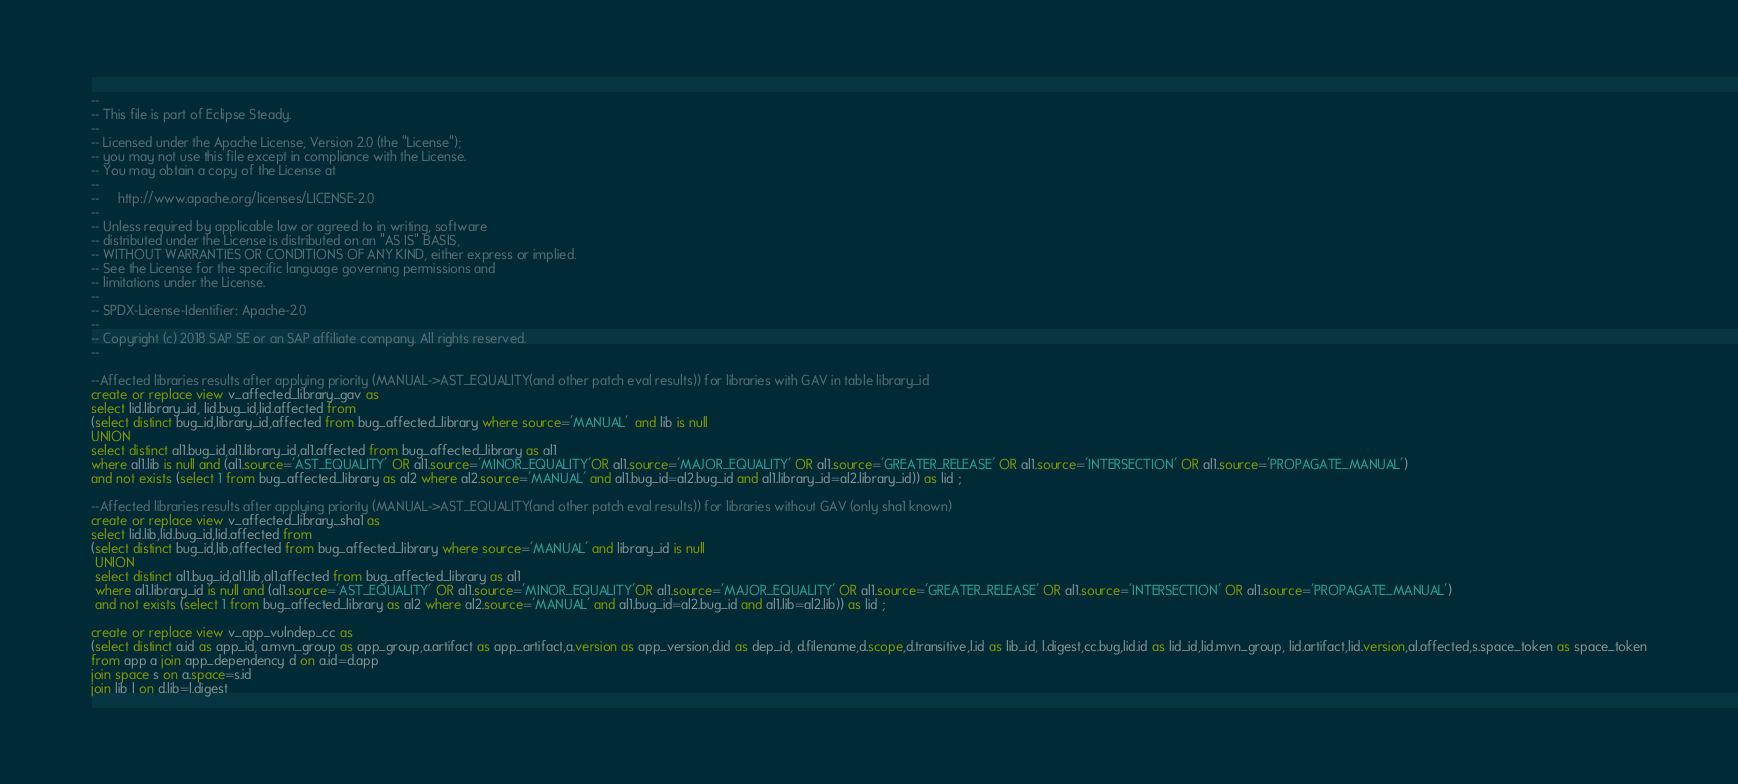<code> <loc_0><loc_0><loc_500><loc_500><_SQL_>--
-- This file is part of Eclipse Steady.
--
-- Licensed under the Apache License, Version 2.0 (the "License");
-- you may not use this file except in compliance with the License.
-- You may obtain a copy of the License at
--
--     http://www.apache.org/licenses/LICENSE-2.0
--
-- Unless required by applicable law or agreed to in writing, software
-- distributed under the License is distributed on an "AS IS" BASIS,
-- WITHOUT WARRANTIES OR CONDITIONS OF ANY KIND, either express or implied.
-- See the License for the specific language governing permissions and
-- limitations under the License.
--
-- SPDX-License-Identifier: Apache-2.0
--
-- Copyright (c) 2018 SAP SE or an SAP affiliate company. All rights reserved.
--

--Affected libraries results after applying priority (MANUAL->AST_EQUALITY(and other patch eval results)) for libraries with GAV in table library_id
create or replace view v_affected_library_gav as
select lid.library_id, lid.bug_id,lid.affected from 
(select distinct bug_id,library_id,affected from bug_affected_library where source='MANUAL'  and lib is null
UNION 
select distinct al1.bug_id,al1.library_id,al1.affected from bug_affected_library as al1
where al1.lib is null and (al1.source='AST_EQUALITY' OR al1.source='MINOR_EQUALITY'OR al1.source='MAJOR_EQUALITY' OR al1.source='GREATER_RELEASE' OR al1.source='INTERSECTION' OR al1.source='PROPAGATE_MANUAL')
and not exists (select 1 from bug_affected_library as al2 where al2.source='MANUAL' and al1.bug_id=al2.bug_id and al1.library_id=al2.library_id)) as lid ;

--Affected libraries results after applying priority (MANUAL->AST_EQUALITY(and other patch eval results)) for libraries without GAV (only sha1 known)
create or replace view v_affected_library_sha1 as
select lid.lib,lid.bug_id,lid.affected from 
(select distinct bug_id,lib,affected from bug_affected_library where source='MANUAL' and library_id is null 
 UNION 
 select distinct al1.bug_id,al1.lib,al1.affected from bug_affected_library as al1
 where al1.library_id is null and (al1.source='AST_EQUALITY' OR al1.source='MINOR_EQUALITY'OR al1.source='MAJOR_EQUALITY' OR al1.source='GREATER_RELEASE' OR al1.source='INTERSECTION' OR al1.source='PROPAGATE_MANUAL') 
 and not exists (select 1 from bug_affected_library as al2 where al2.source='MANUAL' and al1.bug_id=al2.bug_id and al1.lib=al2.lib)) as lid ;

create or replace view v_app_vulndep_cc as 
(select distinct a.id as app_id, a.mvn_group as app_group,a.artifact as app_artifact,a.version as app_version,d.id as dep_id, d.filename,d.scope,d.transitive,l.id as lib_id, l.digest,cc.bug,lid.id as lid_id,lid.mvn_group, lid.artifact,lid.version,al.affected,s.space_token as space_token
from app a join app_dependency d on a.id=d.app
join space s on a.space=s.id
join lib l on d.lib=l.digest</code> 